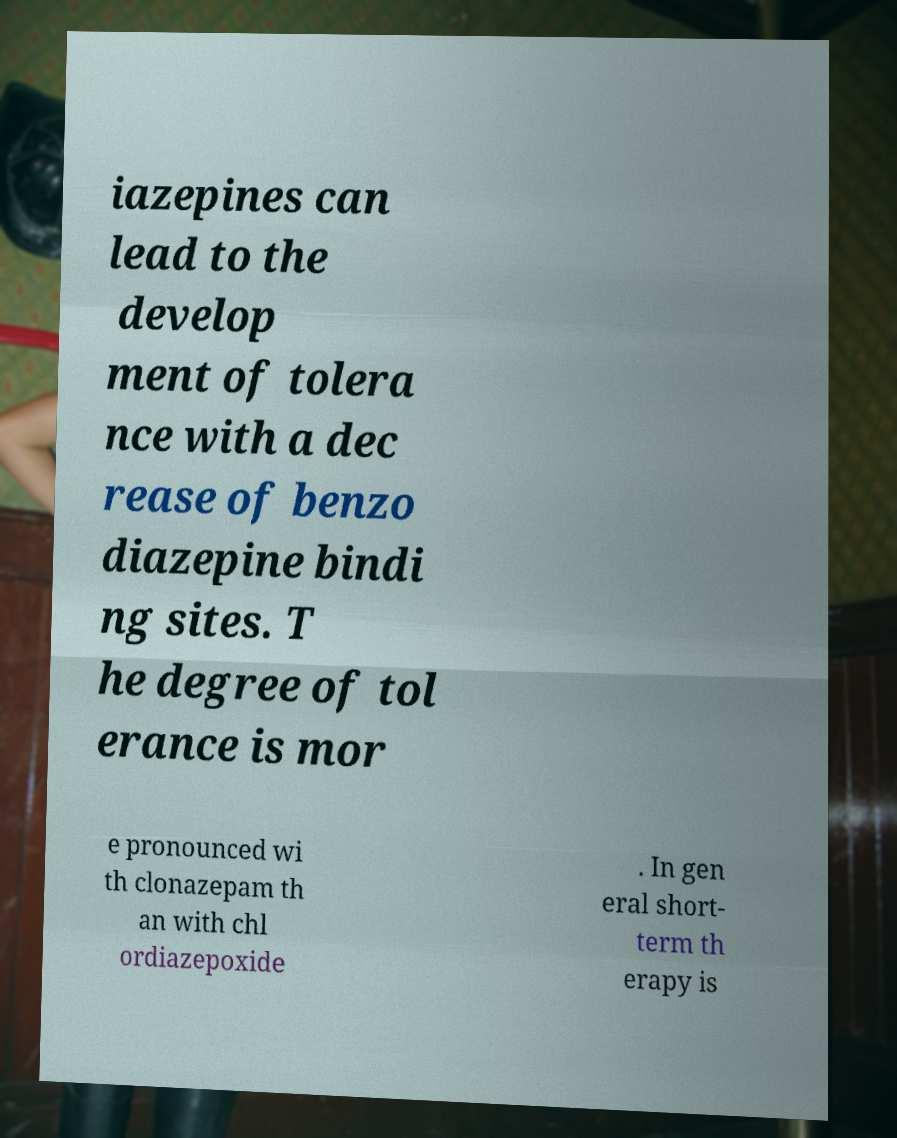Can you accurately transcribe the text from the provided image for me? iazepines can lead to the develop ment of tolera nce with a dec rease of benzo diazepine bindi ng sites. T he degree of tol erance is mor e pronounced wi th clonazepam th an with chl ordiazepoxide . In gen eral short- term th erapy is 